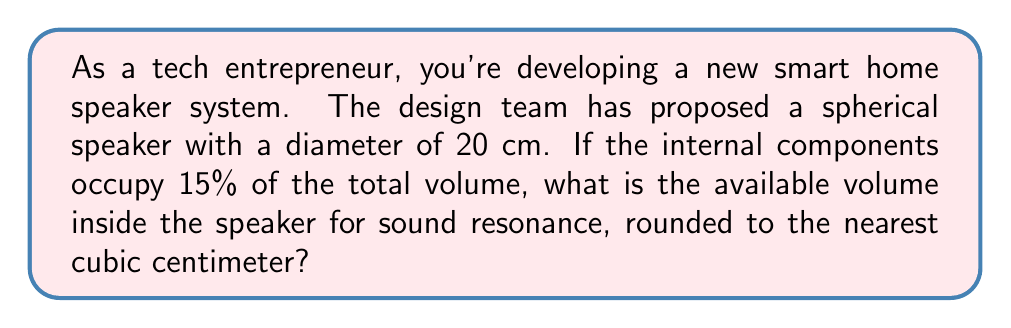Help me with this question. Let's approach this problem step-by-step:

1) First, we need to calculate the total volume of the spherical speaker. The formula for the volume of a sphere is:

   $$V = \frac{4}{3}\pi r^3$$

   where $r$ is the radius of the sphere.

2) The diameter is given as 20 cm, so the radius is 10 cm.

3) Let's substitute this into our formula:

   $$V = \frac{4}{3}\pi (10\text{ cm})^3$$

4) Simplify:
   
   $$V = \frac{4}{3}\pi (1000\text{ cm}^3) = \frac{4000}{3}\pi\text{ cm}^3$$

5) Calculate (use $\pi \approx 3.14159$):

   $$V \approx 4188.79\text{ cm}^3$$

6) Now, we're told that internal components occupy 15% of this volume. So the available volume for sound resonance is 85% of the total volume.

7) Calculate 85% of the total volume:

   $$0.85 \times 4188.79\text{ cm}^3 \approx 3560.47\text{ cm}^3$$

8) Rounding to the nearest cubic centimeter:

   $$3560\text{ cm}^3$$
Answer: $3560\text{ cm}^3$ 